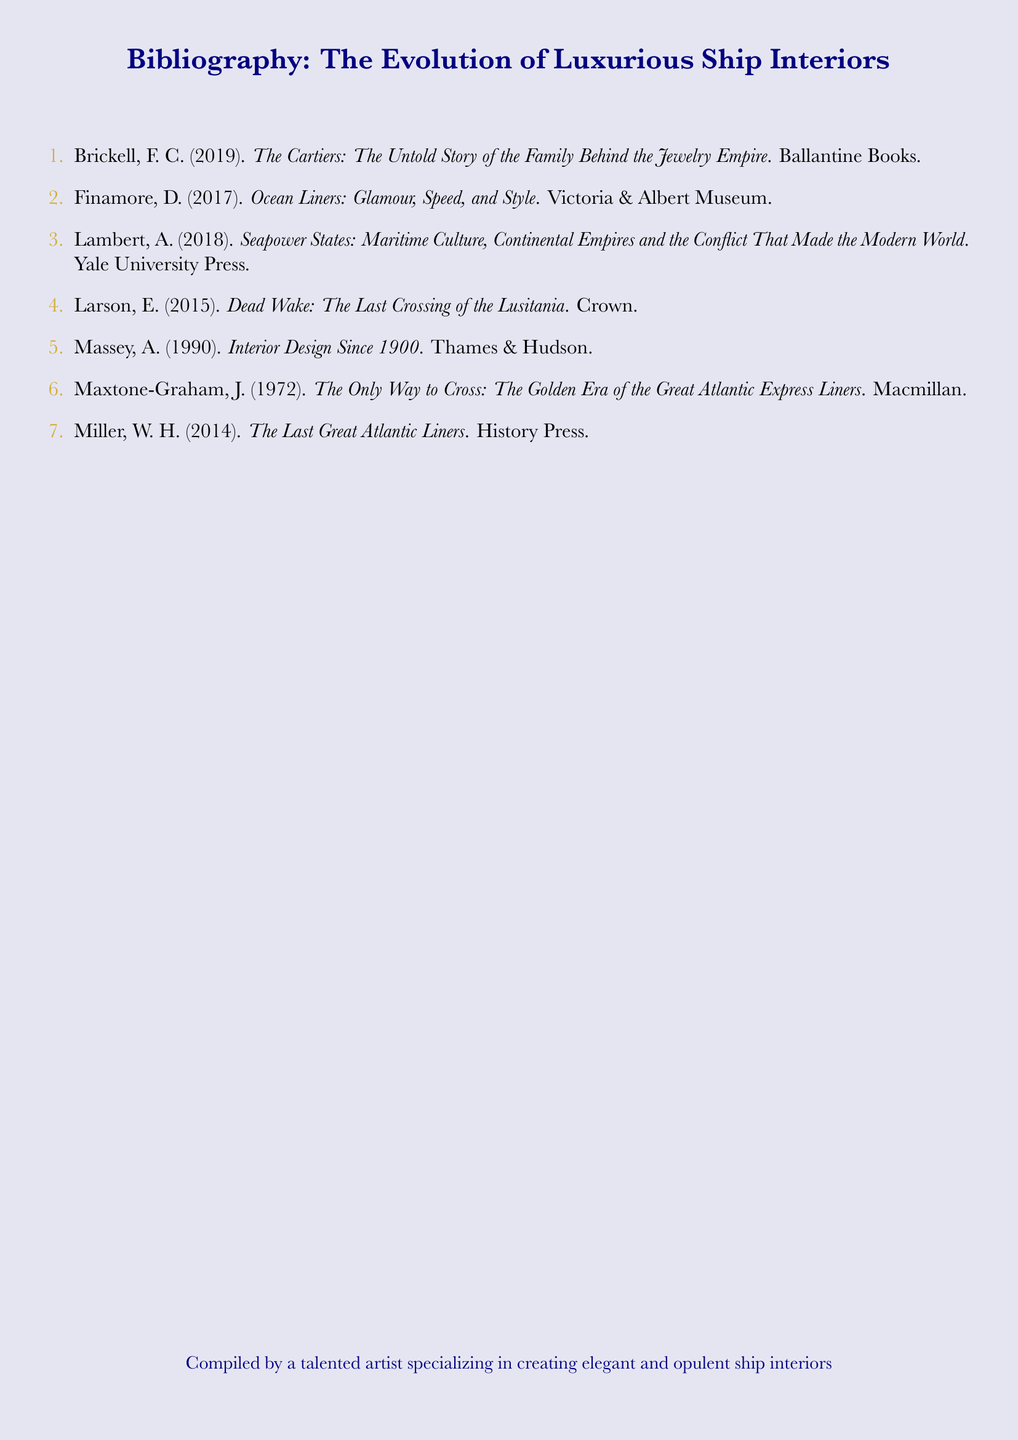What is the title of the first cited work? The title is listed at the beginning of the first reference in the bibliography.
Answer: The Cartiers: The Untold Story of the Family Behind the Jewelry Empire Who is the author of "Ocean Liners: Glamour, Speed, and Style"? The author's name is provided right before the title of this specific work.
Answer: D. Finamore In what year was "Dead Wake: The Last Crossing of the Lusitania" published? The publication year is included next to the author's name in the citation.
Answer: 2015 How many total references are included in the bibliography? This can be determined by counting the number of items listed in the bibliography section.
Answer: 7 What publisher published "Interior Design Since 1900"? The name of the publisher is mentioned directly after the title in the citation.
Answer: Thames & Hudson Which reference has the author's first initial "A."? The author initials can be identified by checking the entries in the document for the relevant initials.
Answer: A. Massey What color accent is used for the section titles? The documented color choice is specified at the start of the document for styling.
Answer: Gold accent 